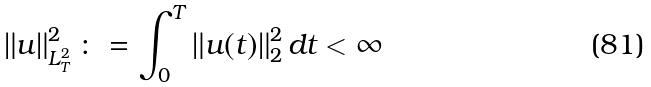<formula> <loc_0><loc_0><loc_500><loc_500>\left \| u \right \| _ { L ^ { 2 } _ { T } } ^ { 2 } \colon = \int _ { 0 } ^ { T } \left \| u ( t ) \right \| _ { 2 } ^ { 2 } d t < \infty</formula> 